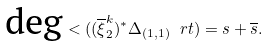Convert formula to latex. <formula><loc_0><loc_0><loc_500><loc_500>\text {deg} < ( ( \overline { \xi } ^ { k } _ { 2 } ) ^ { * } \Delta _ { ( 1 , 1 ) } \ r t ) = s + \overline { s } .</formula> 